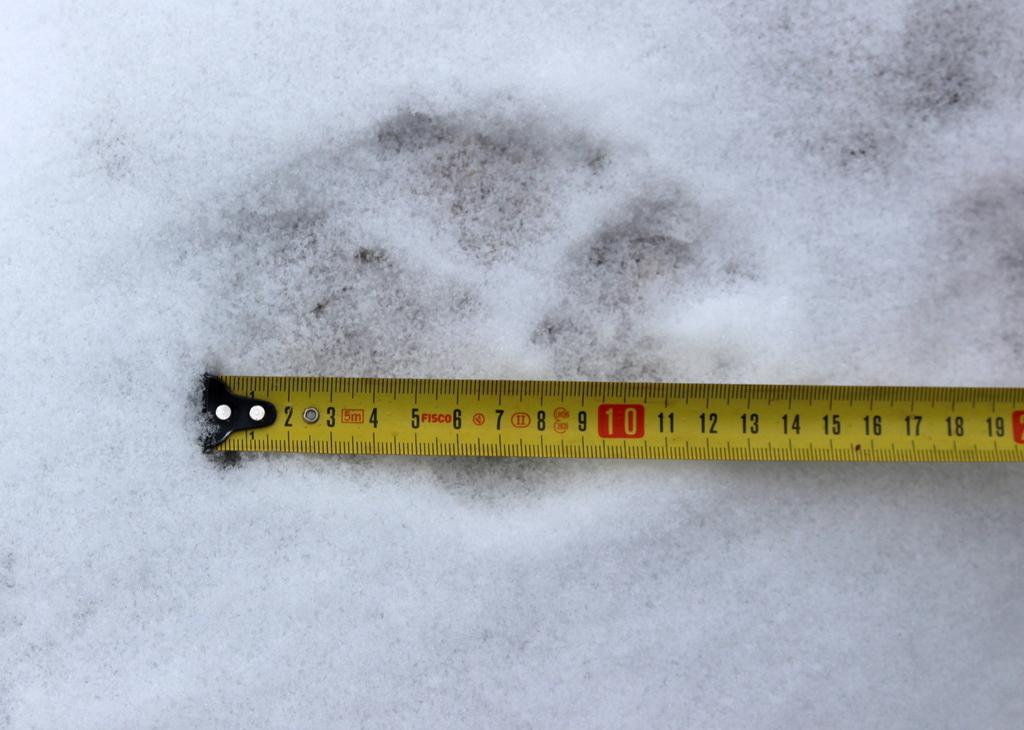What number is written in red on the measuring tape?
Offer a very short reply. 10. What unit of measurement is the measuring tape in?
Keep it short and to the point. Inches. 